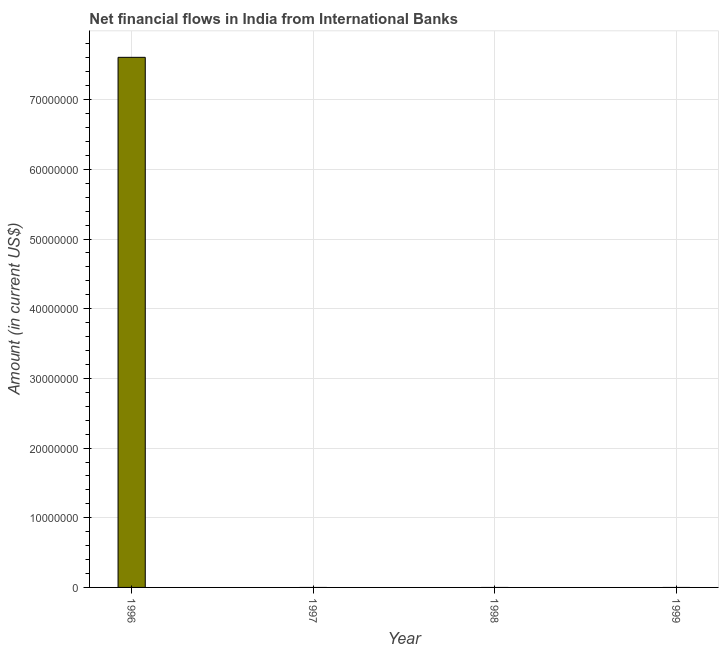Does the graph contain any zero values?
Make the answer very short. Yes. What is the title of the graph?
Your answer should be compact. Net financial flows in India from International Banks. What is the label or title of the Y-axis?
Provide a succinct answer. Amount (in current US$). What is the net financial flows from ibrd in 1996?
Ensure brevity in your answer.  7.61e+07. Across all years, what is the maximum net financial flows from ibrd?
Provide a succinct answer. 7.61e+07. In which year was the net financial flows from ibrd maximum?
Ensure brevity in your answer.  1996. What is the sum of the net financial flows from ibrd?
Provide a short and direct response. 7.61e+07. What is the average net financial flows from ibrd per year?
Your answer should be very brief. 1.90e+07. In how many years, is the net financial flows from ibrd greater than 38000000 US$?
Give a very brief answer. 1. What is the difference between the highest and the lowest net financial flows from ibrd?
Keep it short and to the point. 7.61e+07. Are all the bars in the graph horizontal?
Provide a succinct answer. No. How many years are there in the graph?
Provide a succinct answer. 4. What is the difference between two consecutive major ticks on the Y-axis?
Your answer should be compact. 1.00e+07. What is the Amount (in current US$) of 1996?
Ensure brevity in your answer.  7.61e+07. What is the Amount (in current US$) of 1997?
Offer a terse response. 0. What is the Amount (in current US$) of 1999?
Give a very brief answer. 0. 